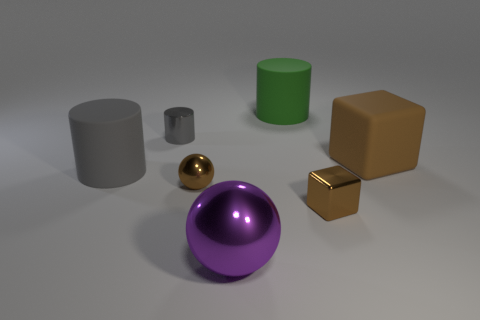Add 1 cylinders. How many objects exist? 8 Subtract all spheres. How many objects are left? 5 Subtract all large cubes. Subtract all large purple objects. How many objects are left? 5 Add 7 gray rubber objects. How many gray rubber objects are left? 8 Add 2 brown shiny cubes. How many brown shiny cubes exist? 3 Subtract 0 green spheres. How many objects are left? 7 